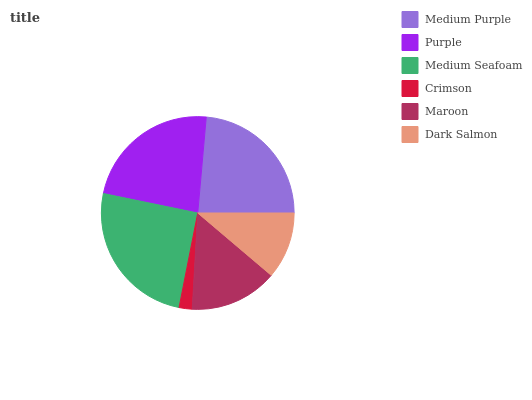Is Crimson the minimum?
Answer yes or no. Yes. Is Medium Seafoam the maximum?
Answer yes or no. Yes. Is Purple the minimum?
Answer yes or no. No. Is Purple the maximum?
Answer yes or no. No. Is Medium Purple greater than Purple?
Answer yes or no. Yes. Is Purple less than Medium Purple?
Answer yes or no. Yes. Is Purple greater than Medium Purple?
Answer yes or no. No. Is Medium Purple less than Purple?
Answer yes or no. No. Is Purple the high median?
Answer yes or no. Yes. Is Maroon the low median?
Answer yes or no. Yes. Is Medium Seafoam the high median?
Answer yes or no. No. Is Medium Seafoam the low median?
Answer yes or no. No. 